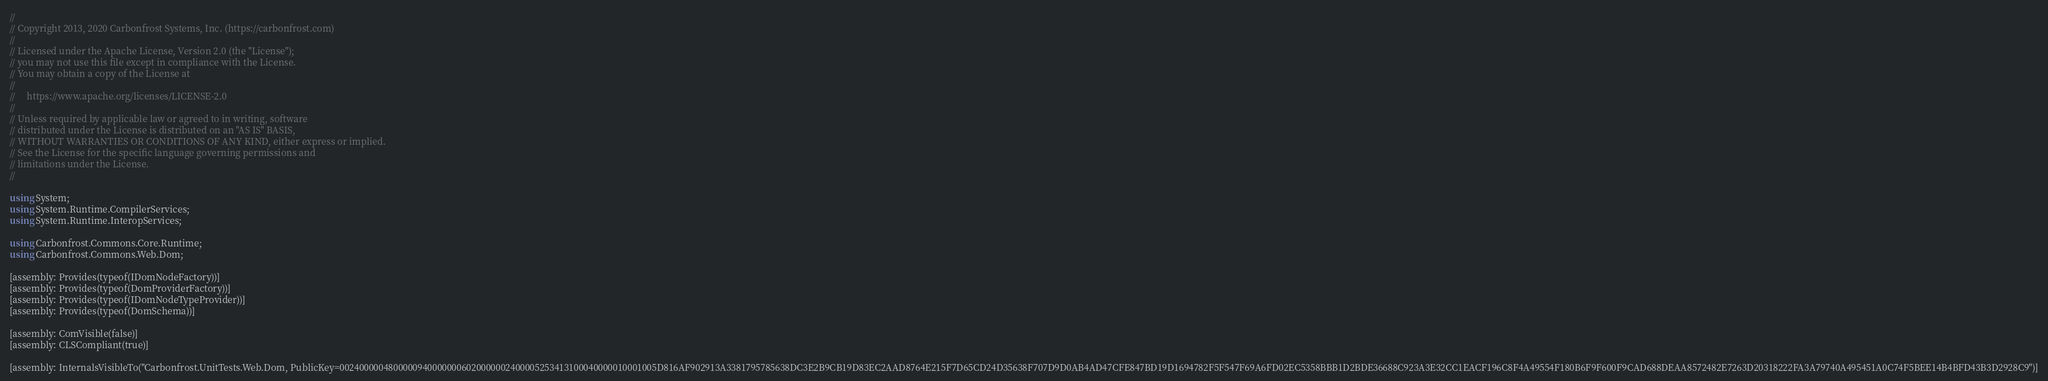Convert code to text. <code><loc_0><loc_0><loc_500><loc_500><_C#_>//
// Copyright 2013, 2020 Carbonfrost Systems, Inc. (https://carbonfrost.com)
//
// Licensed under the Apache License, Version 2.0 (the "License");
// you may not use this file except in compliance with the License.
// You may obtain a copy of the License at
//
//     https://www.apache.org/licenses/LICENSE-2.0
//
// Unless required by applicable law or agreed to in writing, software
// distributed under the License is distributed on an "AS IS" BASIS,
// WITHOUT WARRANTIES OR CONDITIONS OF ANY KIND, either express or implied.
// See the License for the specific language governing permissions and
// limitations under the License.
//

using System;
using System.Runtime.CompilerServices;
using System.Runtime.InteropServices;

using Carbonfrost.Commons.Core.Runtime;
using Carbonfrost.Commons.Web.Dom;

[assembly: Provides(typeof(IDomNodeFactory))]
[assembly: Provides(typeof(DomProviderFactory))]
[assembly: Provides(typeof(IDomNodeTypeProvider))]
[assembly: Provides(typeof(DomSchema))]

[assembly: ComVisible(false)]
[assembly: CLSCompliant(true)]

[assembly: InternalsVisibleTo("Carbonfrost.UnitTests.Web.Dom, PublicKey=00240000048000009400000006020000002400005253413100040000010001005D816AF902913A3381795785638DC3E2B9CB19D83EC2AAD8764E215F7D65CD24D35638F707D9D0AB4AD47CFE847BD19D1694782F5F547F69A6FD02EC5358BBB1D2BDE36688C923A3E32CC1EACF196C8F4A49554F180B6F9F600F9CAD688DEAA8572482E7263D20318222FA3A79740A495451A0C74F5BEE14B4BFD43B3D2928C9")]
</code> 